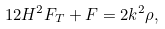<formula> <loc_0><loc_0><loc_500><loc_500>1 2 H ^ { 2 } F _ { T } + F = 2 k ^ { 2 } \rho ,</formula> 